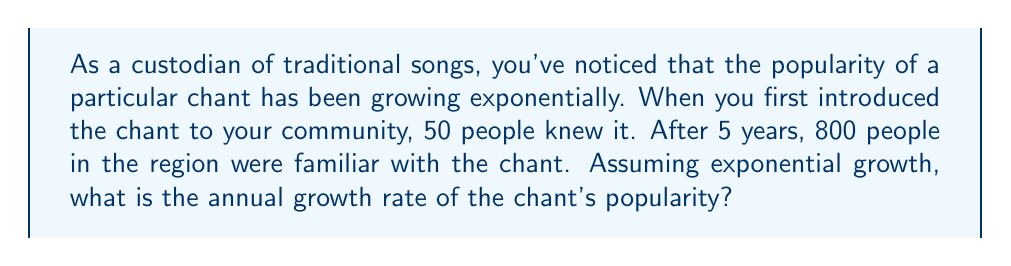Solve this math problem. Let's approach this step-by-step using the exponential growth formula:

1) The exponential growth formula is:
   $$A = P(1 + r)^t$$
   where:
   $A$ is the final amount
   $P$ is the initial amount
   $r$ is the annual growth rate (in decimal form)
   $t$ is the time in years

2) We know:
   $P = 50$ (initial number of people)
   $A = 800$ (final number of people)
   $t = 5$ years

3) Let's plug these into our formula:
   $$800 = 50(1 + r)^5$$

4) Divide both sides by 50:
   $$16 = (1 + r)^5$$

5) Take the 5th root of both sides:
   $$\sqrt[5]{16} = 1 + r$$

6) Simplify:
   $$16^{\frac{1}{5}} = 1 + r$$

7) Calculate (you can use a calculator for this):
   $$1.7411 \approx 1 + r$$

8) Subtract 1 from both sides:
   $$0.7411 \approx r$$

9) Convert to a percentage:
   $$74.11\% \approx r$$

Therefore, the annual growth rate is approximately 74.11%.
Answer: 74.11% 